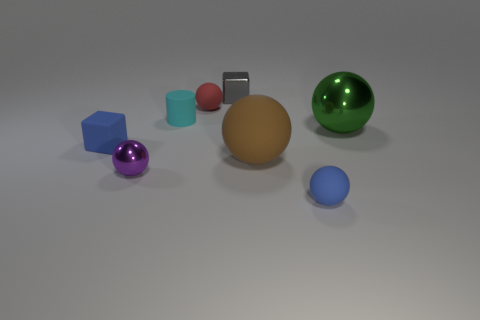Subtract all small spheres. How many spheres are left? 2 Add 1 brown rubber things. How many objects exist? 9 Subtract all brown spheres. How many spheres are left? 4 Subtract 1 spheres. How many spheres are left? 4 Subtract all balls. How many objects are left? 3 Subtract all red balls. Subtract all brown cylinders. How many balls are left? 4 Subtract all big blue rubber cubes. Subtract all tiny cyan rubber cylinders. How many objects are left? 7 Add 5 tiny blue blocks. How many tiny blue blocks are left? 6 Add 5 tiny cyan rubber cylinders. How many tiny cyan rubber cylinders exist? 6 Subtract 0 purple blocks. How many objects are left? 8 